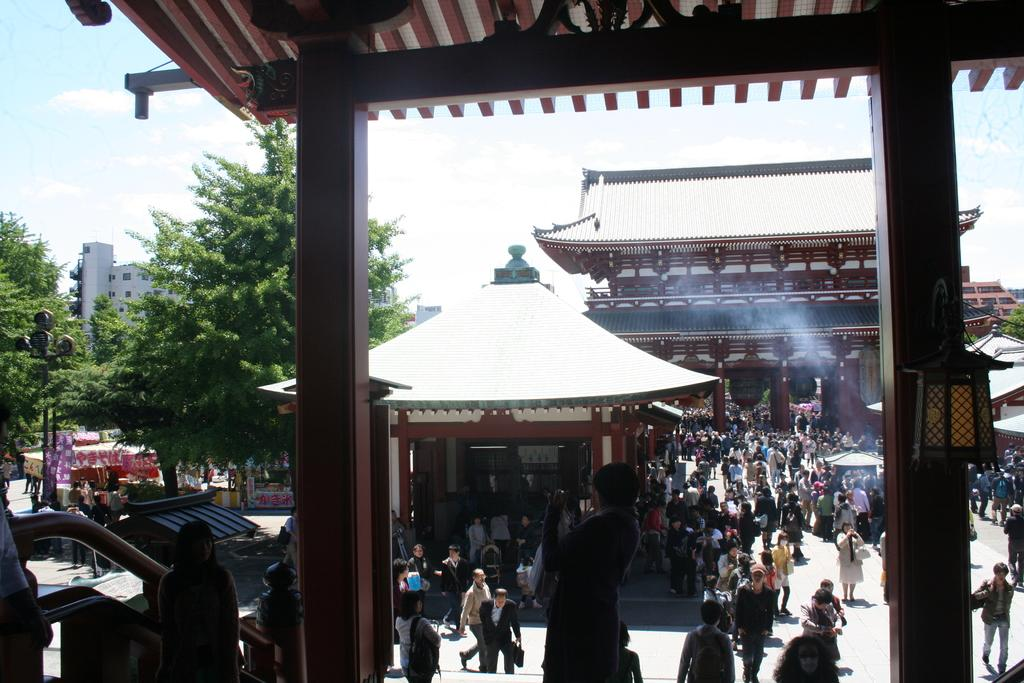What type of structure is shown in the image? The image depicts a shed. What can be seen in the background of the image? The sky is visible in the background, and it is cloudy. What type of vegetation is present in the image? There are trees visible in the image. What other structures can be seen in the image? There are buildings, a store, and stalls in the image. What is the source of light in the image? A light pole is present in the image, and a lamp is attached to a wooden pillar. Are there any people visible in the image? Yes, people are visible in the image. What type of test is being conducted on the horse in the image? There is no horse present in the image, and therefore no test is being conducted. 